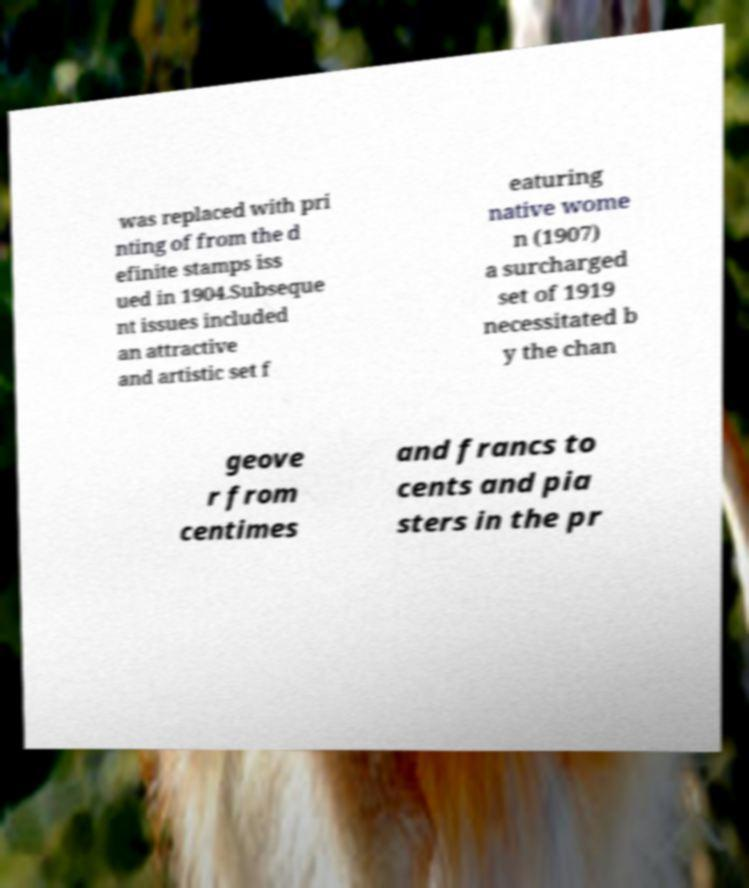There's text embedded in this image that I need extracted. Can you transcribe it verbatim? was replaced with pri nting of from the d efinite stamps iss ued in 1904.Subseque nt issues included an attractive and artistic set f eaturing native wome n (1907) a surcharged set of 1919 necessitated b y the chan geove r from centimes and francs to cents and pia sters in the pr 